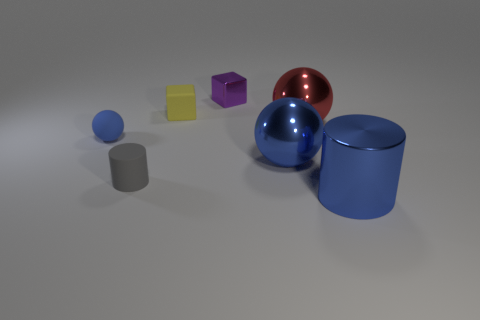What is the material of the purple block? The purple block appears to have a smooth, reflective surface similar to polished metal, indicating that it is likely rendered to emulate a metallic material in this image. 